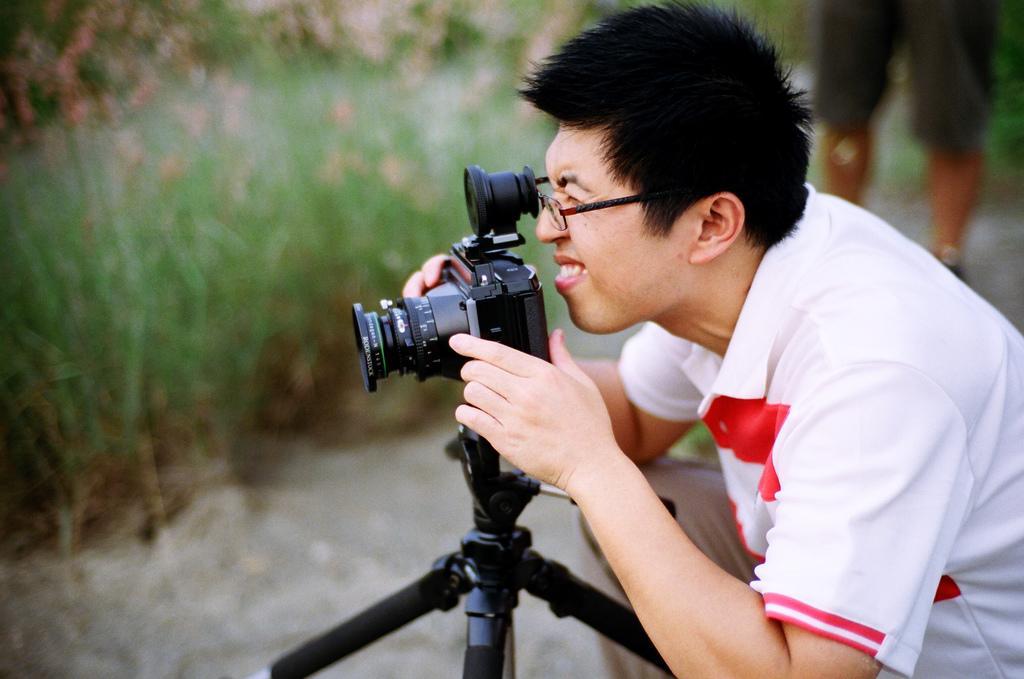Could you give a brief overview of what you see in this image? In this picture we can see two people on the ground where a man holding camera with his hands and in the background we can see plants and it is blurry. 